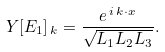<formula> <loc_0><loc_0><loc_500><loc_500>Y [ E _ { 1 } ] _ { \, k } = \frac { e ^ { \, i \, k \cdot x } } { \sqrt { L _ { 1 } L _ { 2 } L _ { 3 } } } .</formula> 